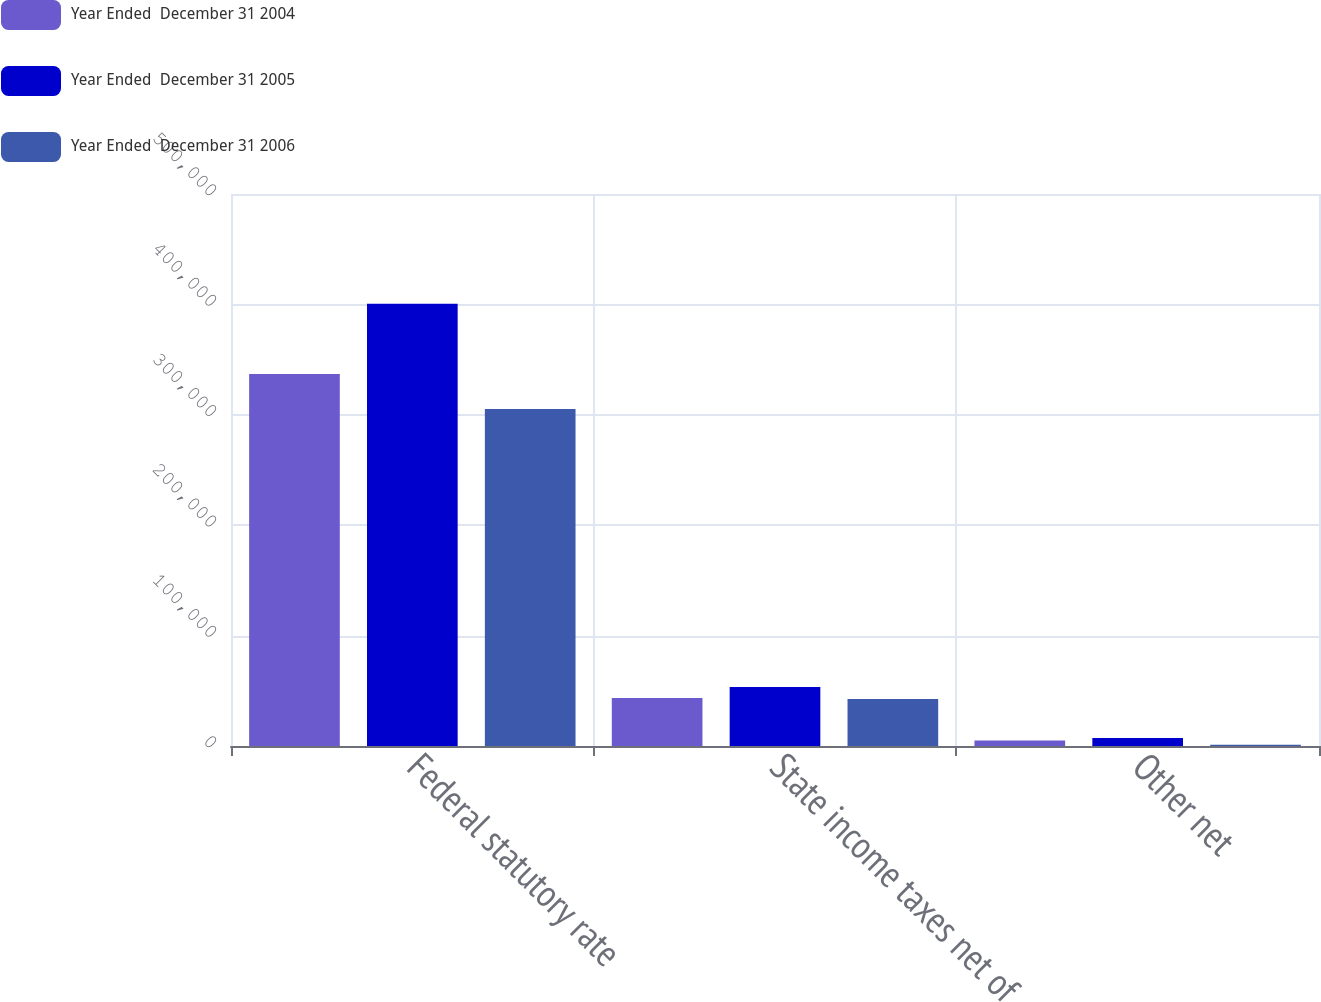<chart> <loc_0><loc_0><loc_500><loc_500><stacked_bar_chart><ecel><fcel>Federal statutory rate<fcel>State income taxes net of<fcel>Other net<nl><fcel>Year Ended  December 31 2004<fcel>337040<fcel>43491<fcel>4972<nl><fcel>Year Ended  December 31 2005<fcel>400547<fcel>53501<fcel>7188<nl><fcel>Year Ended  December 31 2006<fcel>305202<fcel>42521<fcel>1078<nl></chart> 